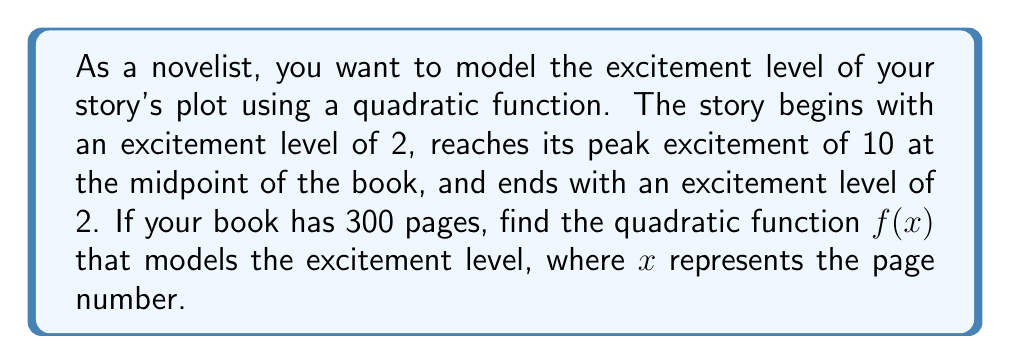Can you solve this math problem? Let's approach this step-by-step:

1) The general form of a quadratic function is $f(x) = a(x-h)^2 + k$, where $(h,k)$ is the vertex.

2) We know the vertex is at the midpoint of the book (150 pages) with an excitement level of 10:
   $(h,k) = (150, 10)$

3) So our function takes the form: $f(x) = a(x-150)^2 + 10$

4) We need to find $a$ using one of the other points. Let's use the beginning of the book:
   When $x = 0$, $f(0) = 2$

5) Substitute these values into our function:
   $2 = a(0-150)^2 + 10$
   $2 = 22500a + 10$
   $-8 = 22500a$
   $a = -\frac{8}{22500} = -\frac{1}{2812.5}$

6) Therefore, our quadratic function is:
   $f(x) = -\frac{1}{2812.5}(x-150)^2 + 10$

7) We can verify this works for the end of the book:
   $f(300) = -\frac{1}{2812.5}(300-150)^2 + 10 = -\frac{1}{2812.5}(150)^2 + 10 = 2$
Answer: $f(x) = -\frac{1}{2812.5}(x-150)^2 + 10$ 